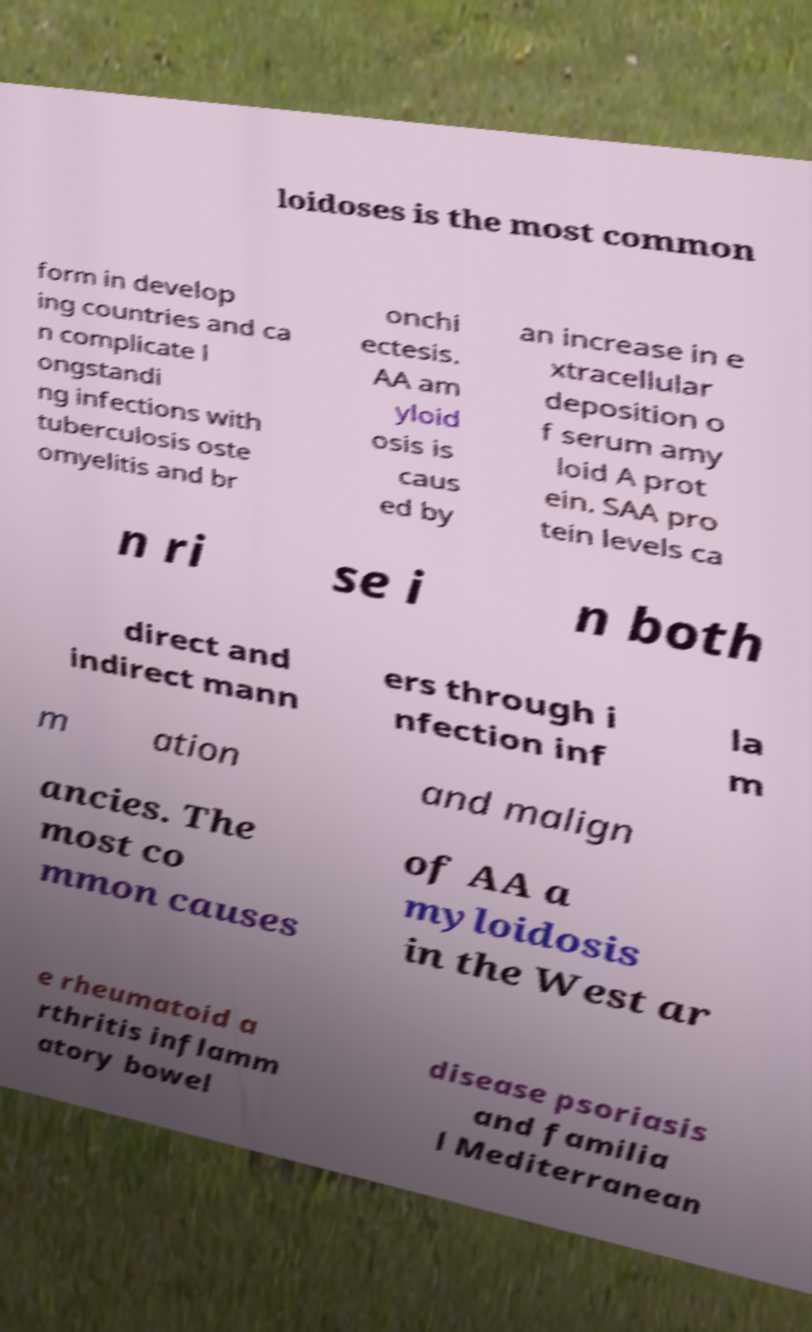Could you assist in decoding the text presented in this image and type it out clearly? loidoses is the most common form in develop ing countries and ca n complicate l ongstandi ng infections with tuberculosis oste omyelitis and br onchi ectesis. AA am yloid osis is caus ed by an increase in e xtracellular deposition o f serum amy loid A prot ein. SAA pro tein levels ca n ri se i n both direct and indirect mann ers through i nfection inf la m m ation and malign ancies. The most co mmon causes of AA a myloidosis in the West ar e rheumatoid a rthritis inflamm atory bowel disease psoriasis and familia l Mediterranean 